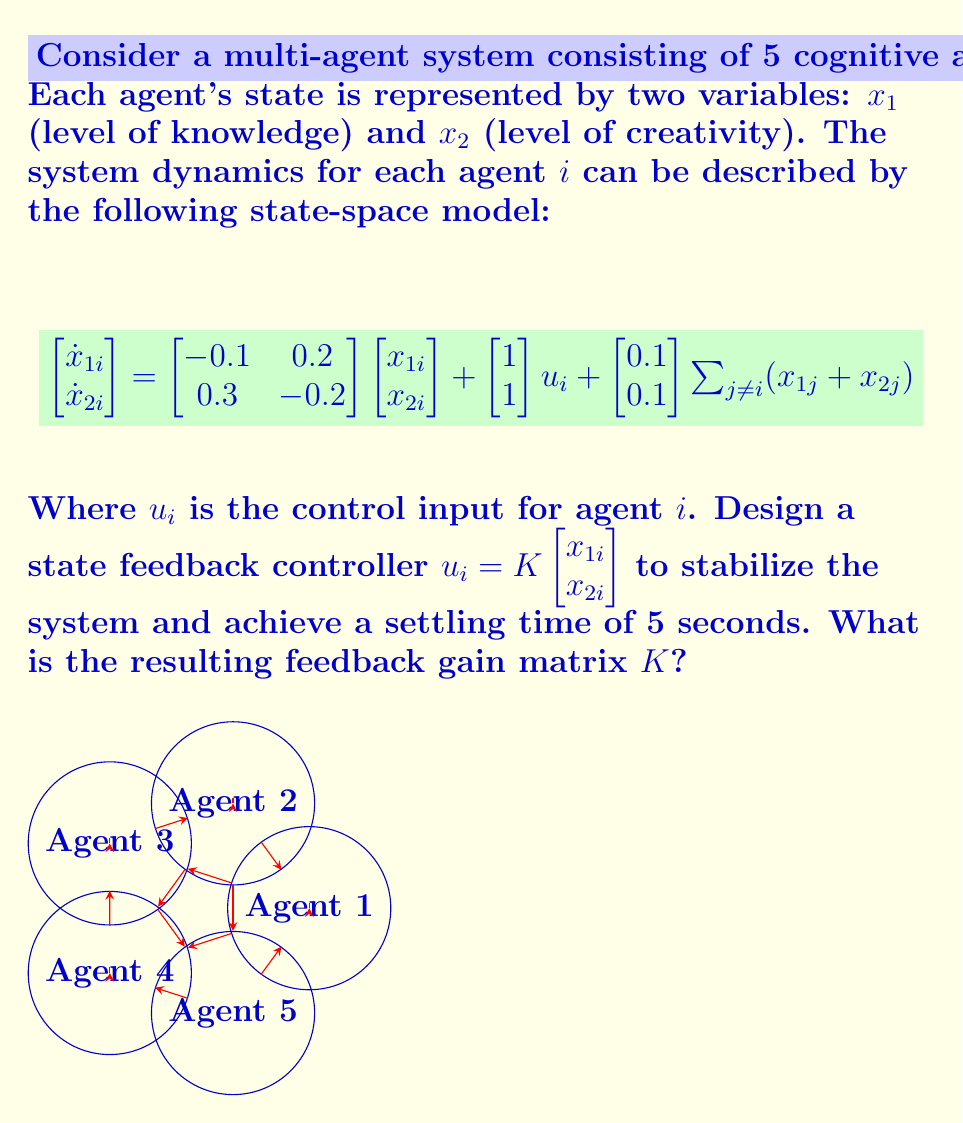Help me with this question. To design the state feedback controller, we'll follow these steps:

1) First, we need to determine the desired closed-loop poles. For a settling time of 5 seconds, we can use the rule of thumb that relates settling time ($t_s$) to the dominant pole ($p$):

   $t_s \approx \frac{4}{|\text{Re}(p)|}$

   Solving for $p$: $p = -\frac{4}{5} = -0.8$

2) We'll place both poles at -0.8 for simplicity. The characteristic equation is:

   $(s + 0.8)^2 = s^2 + 1.6s + 0.64$

3) Now, we need to find the closed-loop characteristic equation. The closed-loop system matrix is:

   $A_{cl} = A + BK = \begin{bmatrix} -0.1 & 0.2 \\ 0.3 & -0.2 \end{bmatrix} + \begin{bmatrix} 1 \\ 1 \end{bmatrix} \begin{bmatrix} k_1 & k_2 \end{bmatrix}$

   $A_{cl} = \begin{bmatrix} -0.1+k_1 & 0.2+k_2 \\ 0.3+k_1 & -0.2+k_2 \end{bmatrix}$

4) The characteristic equation of $A_{cl}$ is:

   $\det(sI - A_{cl}) = s^2 + (0.3-k_1-k_2)s + (0.02-0.1k_1+0.2k_2)$

5) Equating coefficients with the desired characteristic equation:

   $0.3 - k_1 - k_2 = 1.6$
   $0.02 - 0.1k_1 + 0.2k_2 = 0.64$

6) Solving this system of equations:

   $k_1 = -0.9$
   $k_2 = -0.4$

Therefore, the feedback gain matrix $K$ is $\begin{bmatrix} -0.9 & -0.4 \end{bmatrix}$.
Answer: $K = \begin{bmatrix} -0.9 & -0.4 \end{bmatrix}$ 